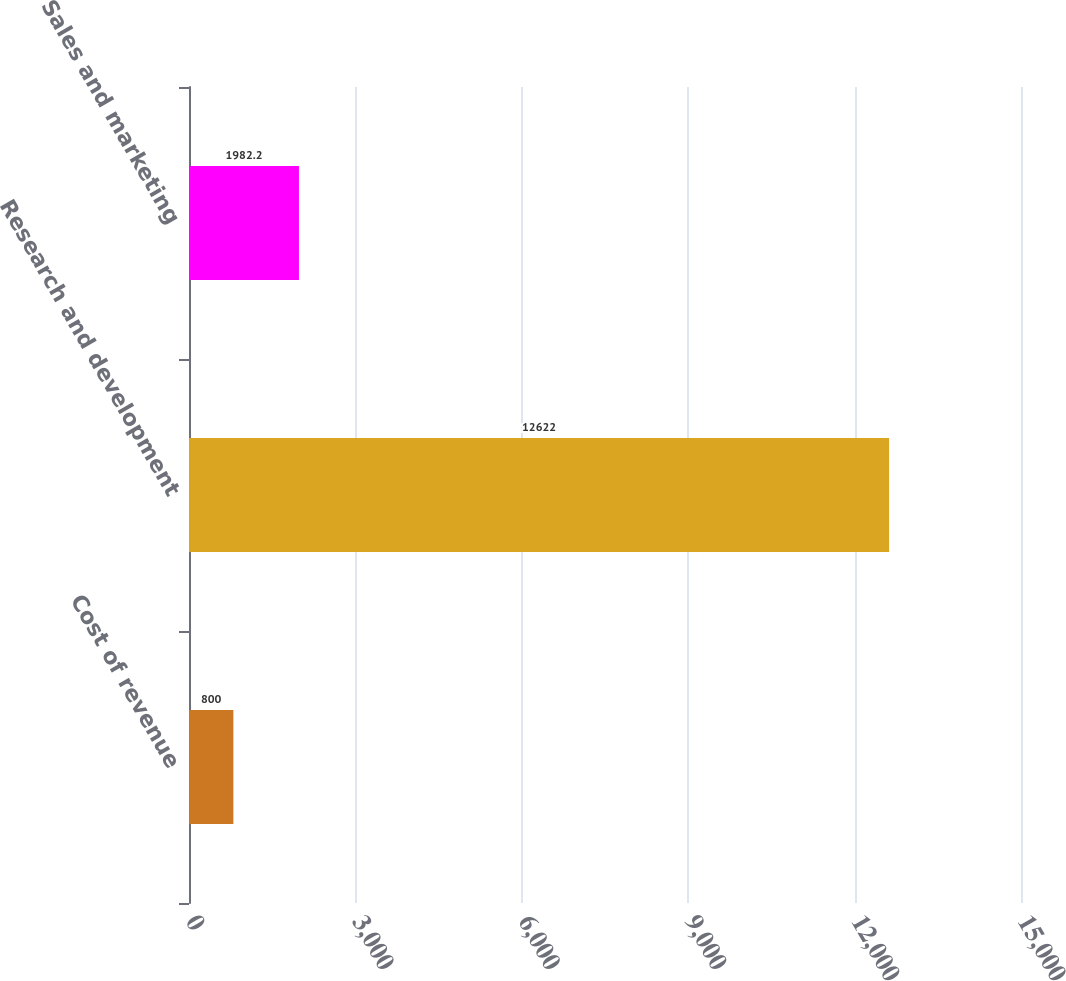Convert chart. <chart><loc_0><loc_0><loc_500><loc_500><bar_chart><fcel>Cost of revenue<fcel>Research and development<fcel>Sales and marketing<nl><fcel>800<fcel>12622<fcel>1982.2<nl></chart> 